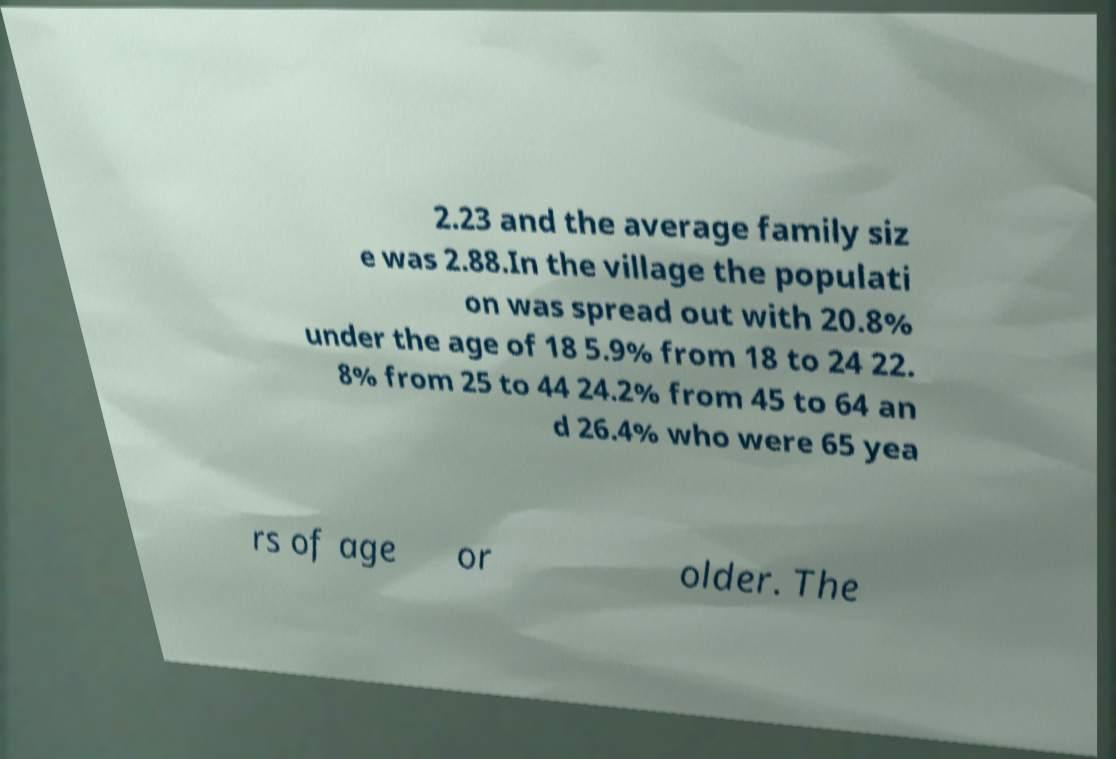Please read and relay the text visible in this image. What does it say? 2.23 and the average family siz e was 2.88.In the village the populati on was spread out with 20.8% under the age of 18 5.9% from 18 to 24 22. 8% from 25 to 44 24.2% from 45 to 64 an d 26.4% who were 65 yea rs of age or older. The 